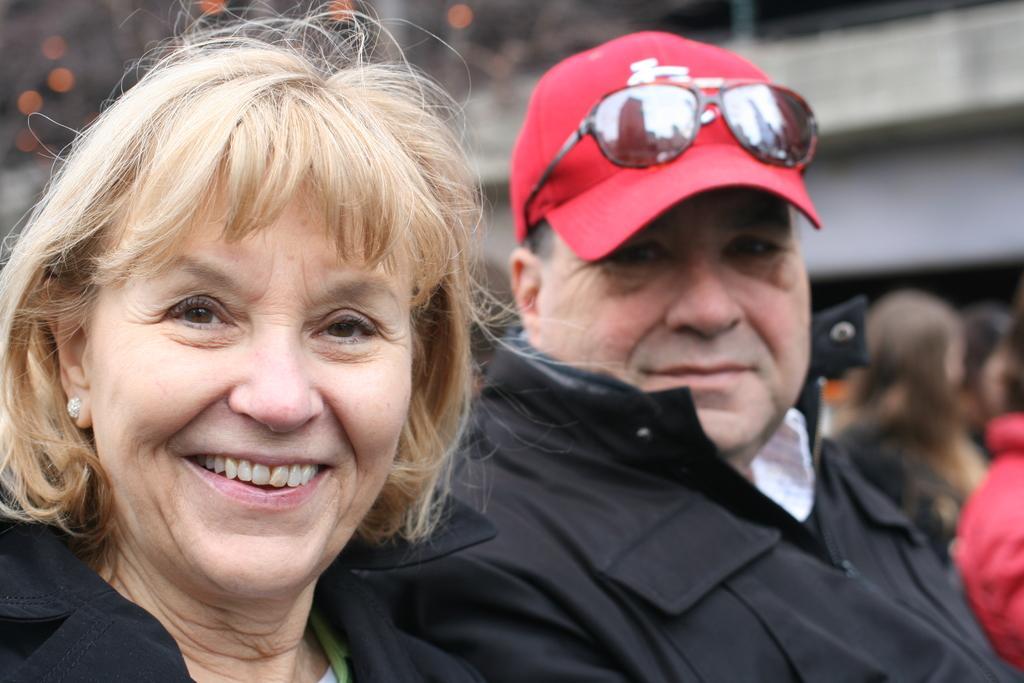Please provide a concise description of this image. In this image, we can see a woman on the left side, she is smiling, we can see a man sitting, he is wearing a red hat, we can see goggles on the hat, in the background we can see some people and there is a wall. 